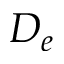Convert formula to latex. <formula><loc_0><loc_0><loc_500><loc_500>D _ { e }</formula> 